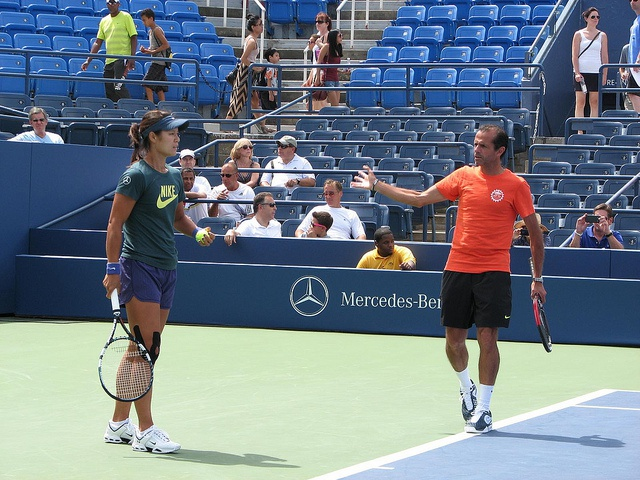Describe the objects in this image and their specific colors. I can see chair in blue, navy, and gray tones, people in blue, black, brown, and gray tones, people in blue, black, gray, navy, and lightgray tones, people in blue, black, navy, brown, and gray tones, and tennis racket in blue, beige, darkgray, gray, and black tones in this image. 